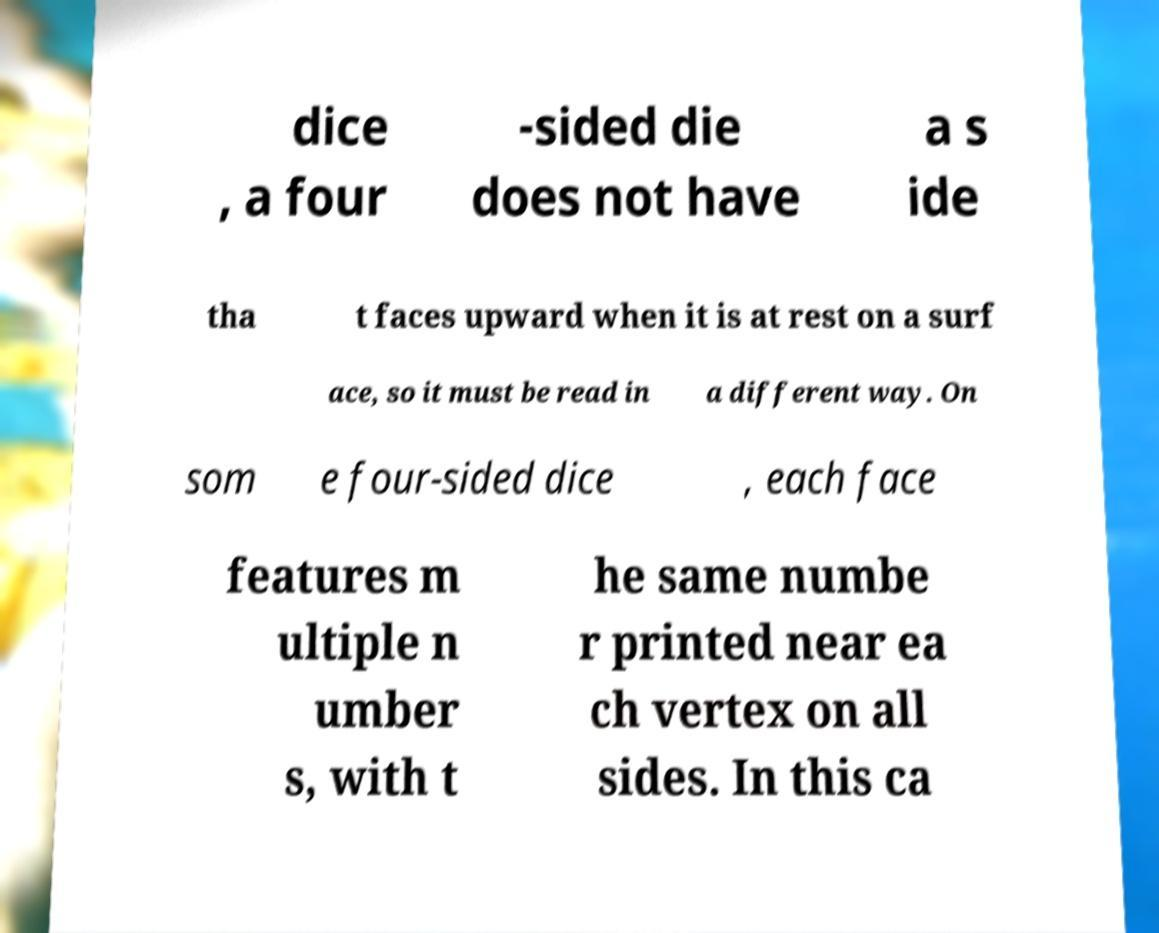Could you extract and type out the text from this image? dice , a four -sided die does not have a s ide tha t faces upward when it is at rest on a surf ace, so it must be read in a different way. On som e four-sided dice , each face features m ultiple n umber s, with t he same numbe r printed near ea ch vertex on all sides. In this ca 